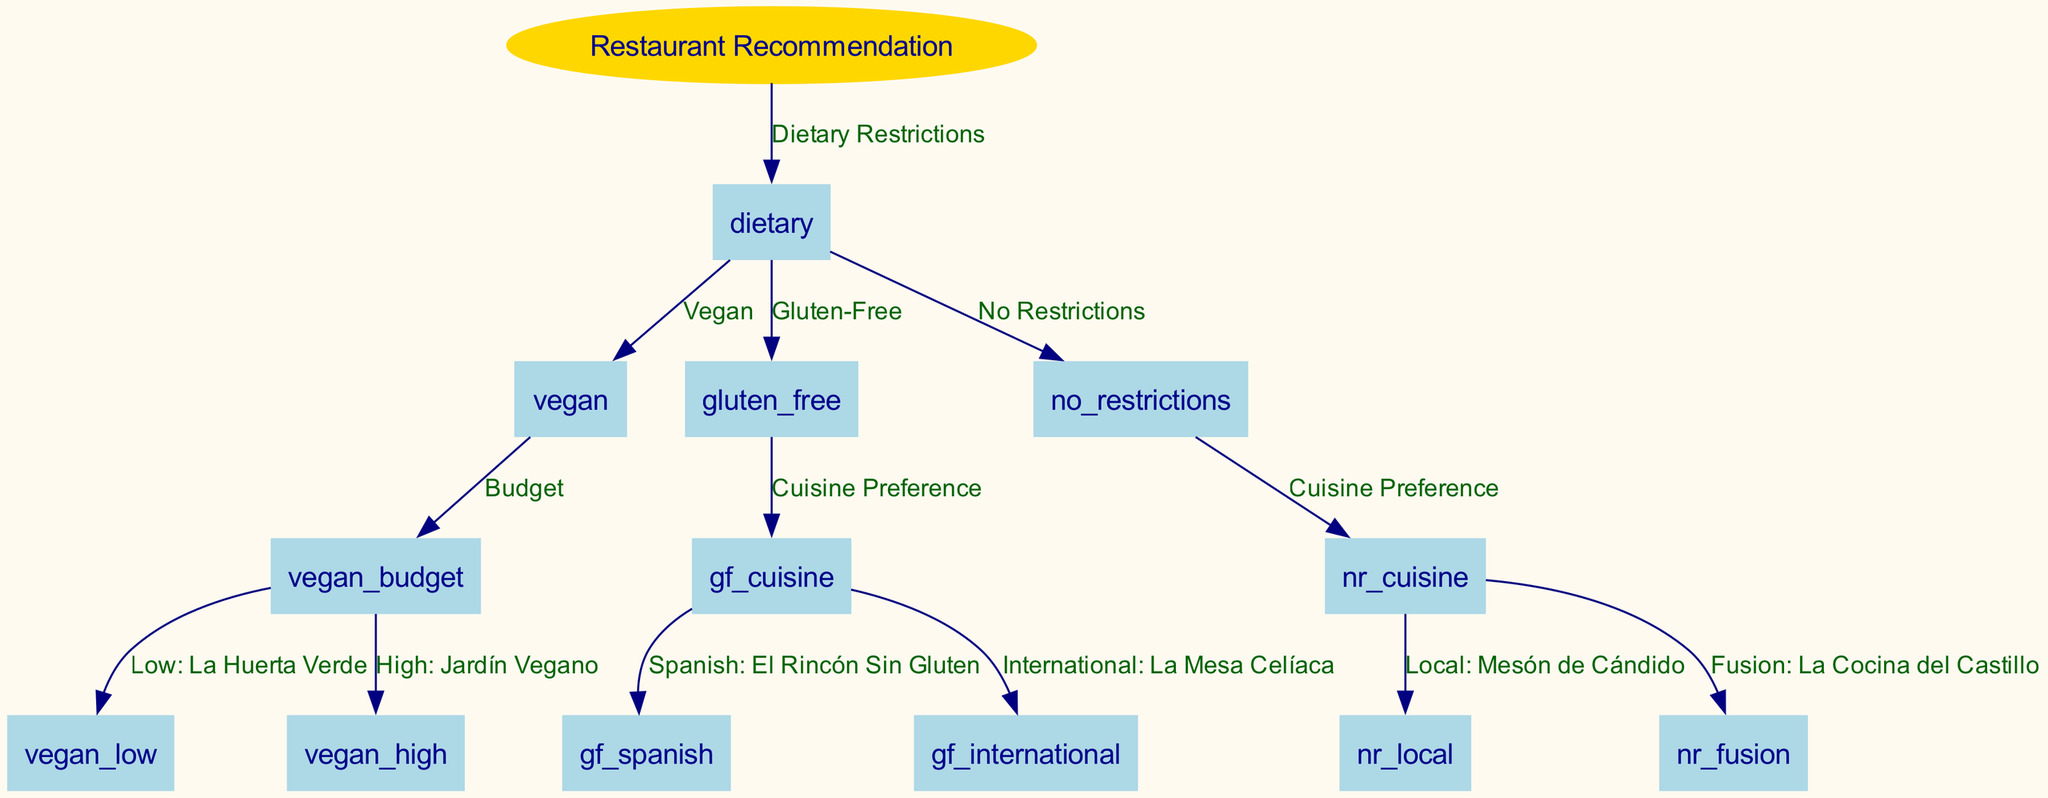What is the first node after the root? The first node after the root is "Dietary Restrictions," which branches out from the root node labeled "Restaurant Recommendation."
Answer: Dietary Restrictions How many restaurants are recommended for vegan options? The vegan options lead to two possible restaurants: "La Huerta Verde" for low budget and "Jardín Vegano" for high budget.
Answer: 2 What are the two available cuisines for gluten-free dining? Under the gluten-free option, the two available cuisines are listed as "Spanish" and "International."
Answer: Spanish and International If a tourist has no dietary restrictions, which restaurant is recommended for local cuisine? For tourists without dietary restrictions who prefer local cuisine, the recommended restaurant is "Mesón de Cándido."
Answer: Mesón de Cándido Which restaurant is suggested for those looking for high-budget vegan food? The decision tree indicates that those looking for high-budget vegan food should go to "Jardín Vegano."
Answer: Jardín Vegano What is the last node for the gluten-free path? The last node along the gluten-free decision path is "La Mesa Celíaca," which is identified as the international gluten-free restaurant.
Answer: La Mesa Celíaca How many total restaurant suggestions are available in the diagram? The diagram provides a total of five restaurant suggestions stemming from different dietary needs and preferences.
Answer: 5 What is the node that indicates the choice of cuisine preference for tourists with no dietary restrictions? The node that indicates the choice of cuisine preference for tourists with no dietary restrictions is labeled as "Cuisine Preference."
Answer: Cuisine Preference 